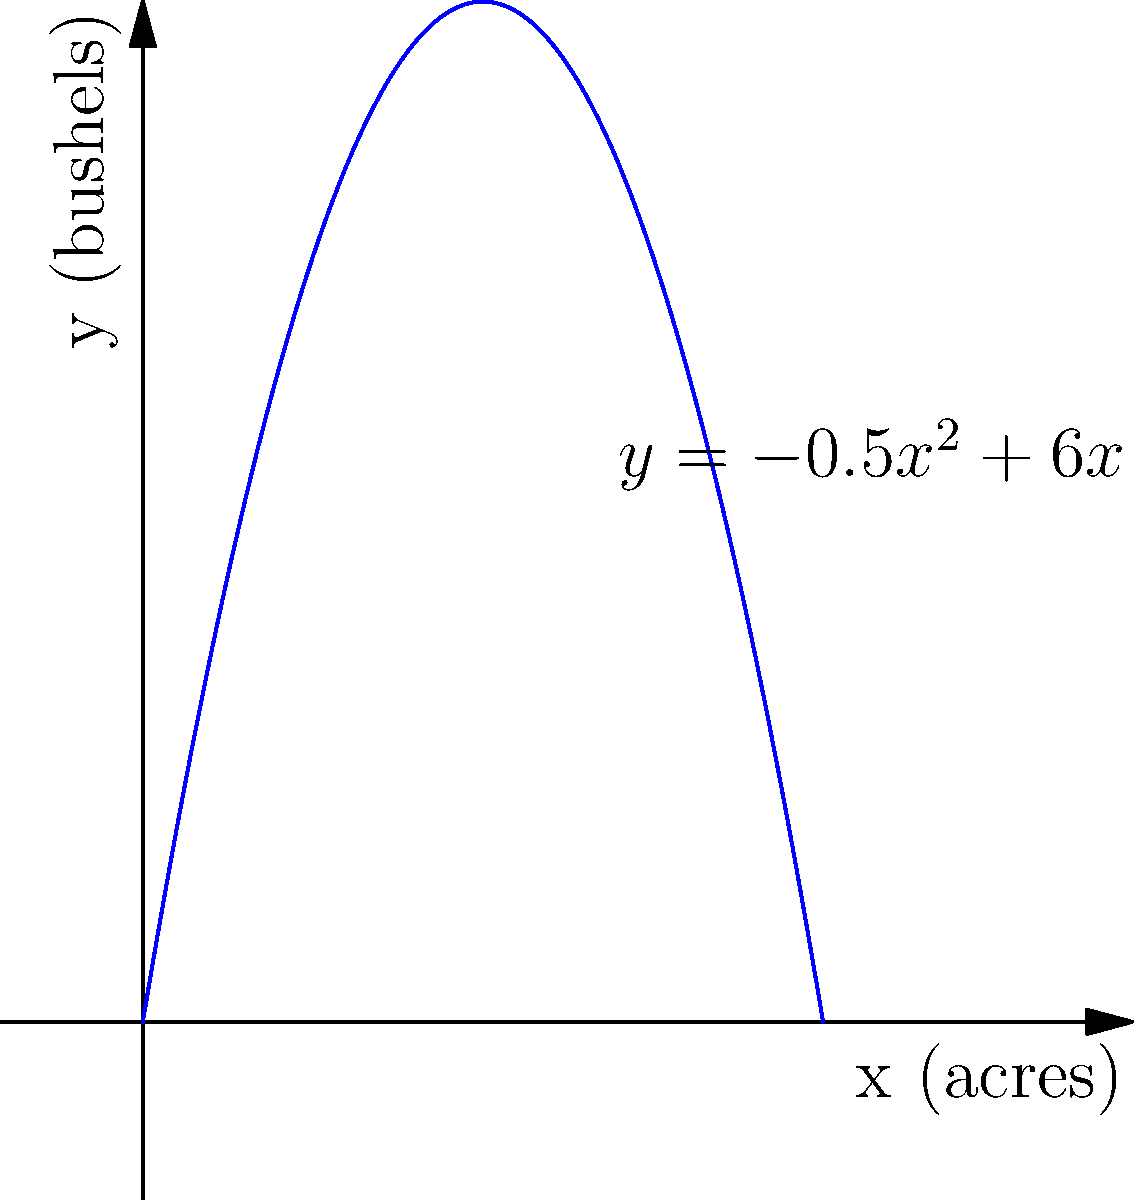A 1950s farm produces wheat, a staple crop during the era of many ex-football players. The yield $y$ in bushels per acre is modeled by the function $y = -0.5x^2 + 6x$, where $x$ is the number of acres planted. What is the maximum yield of wheat, and how many acres should be planted to achieve this maximum? To find the maximum yield, we need to follow these steps:

1) The function $y = -0.5x^2 + 6x$ is a parabola that opens downward (negative coefficient of $x^2$).

2) The maximum point occurs at the vertex of the parabola.

3) For a quadratic function in the form $y = ax^2 + bx + c$, the x-coordinate of the vertex is given by $x = -\frac{b}{2a}$.

4) In our case, $a = -0.5$ and $b = 6$. So:

   $x = -\frac{6}{2(-0.5)} = -\frac{6}{-1} = 6$

5) To find the maximum yield, we substitute $x = 6$ into the original function:

   $y = -0.5(6)^2 + 6(6)$
   $y = -0.5(36) + 36$
   $y = -18 + 36 = 18$

Therefore, the maximum yield is 18 bushels, achieved when 6 acres are planted.
Answer: 18 bushels; 6 acres 